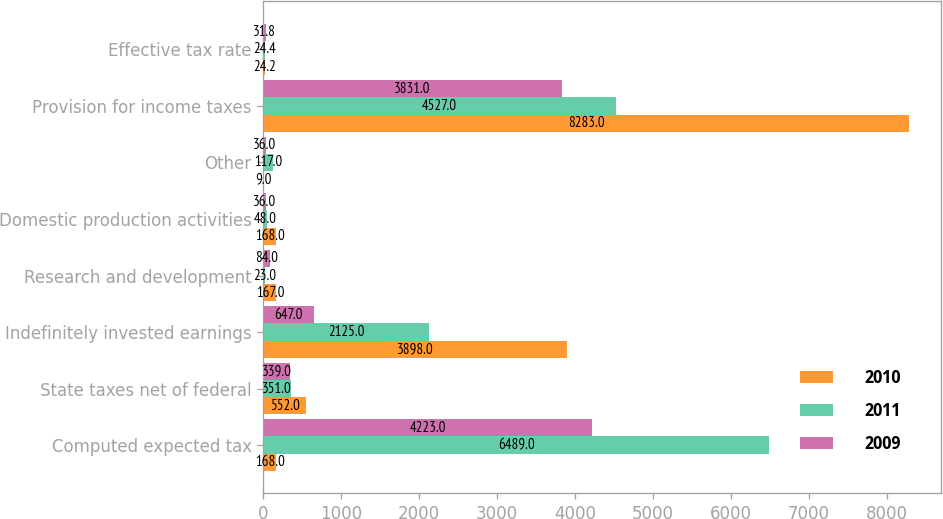Convert chart. <chart><loc_0><loc_0><loc_500><loc_500><stacked_bar_chart><ecel><fcel>Computed expected tax<fcel>State taxes net of federal<fcel>Indefinitely invested earnings<fcel>Research and development<fcel>Domestic production activities<fcel>Other<fcel>Provision for income taxes<fcel>Effective tax rate<nl><fcel>2010<fcel>168<fcel>552<fcel>3898<fcel>167<fcel>168<fcel>9<fcel>8283<fcel>24.2<nl><fcel>2011<fcel>6489<fcel>351<fcel>2125<fcel>23<fcel>48<fcel>117<fcel>4527<fcel>24.4<nl><fcel>2009<fcel>4223<fcel>339<fcel>647<fcel>84<fcel>36<fcel>36<fcel>3831<fcel>31.8<nl></chart> 